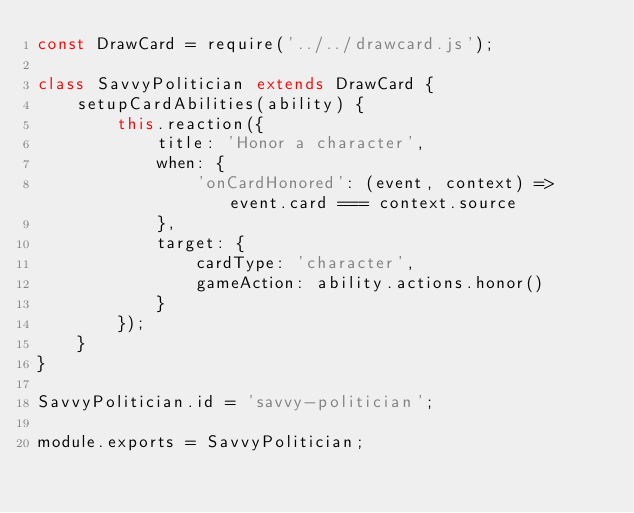Convert code to text. <code><loc_0><loc_0><loc_500><loc_500><_JavaScript_>const DrawCard = require('../../drawcard.js');

class SavvyPolitician extends DrawCard {
    setupCardAbilities(ability) {
        this.reaction({
            title: 'Honor a character',
            when: {
                'onCardHonored': (event, context) => event.card === context.source
            },
            target: {
                cardType: 'character',
                gameAction: ability.actions.honor()
            }
        });
    }
}

SavvyPolitician.id = 'savvy-politician';

module.exports = SavvyPolitician;
</code> 